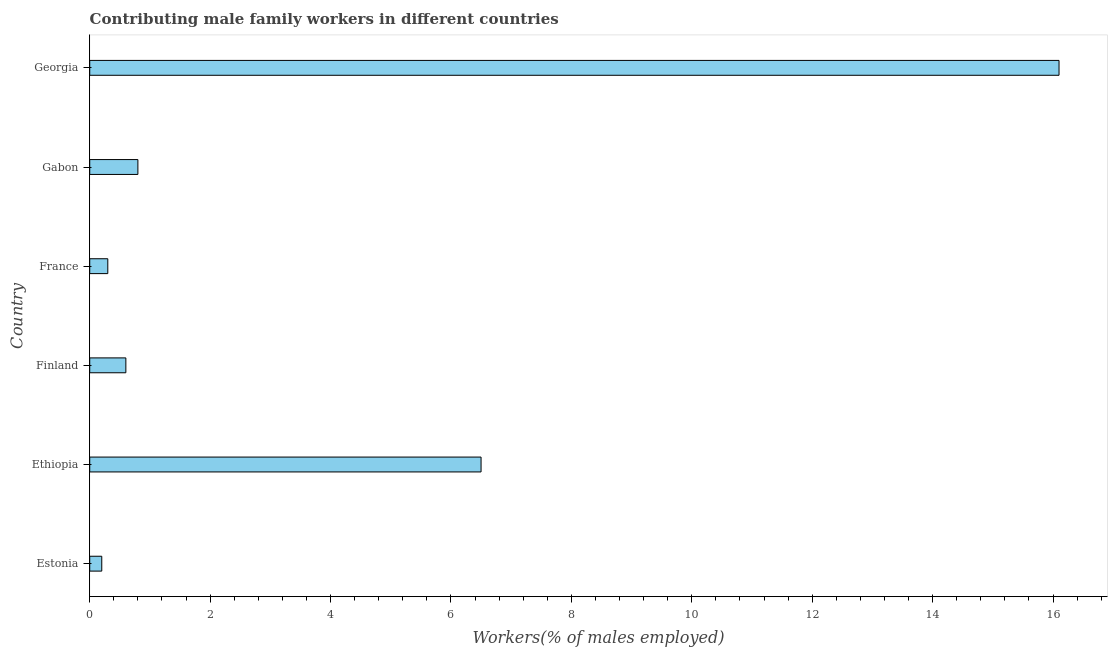What is the title of the graph?
Provide a short and direct response. Contributing male family workers in different countries. What is the label or title of the X-axis?
Provide a short and direct response. Workers(% of males employed). What is the contributing male family workers in Gabon?
Give a very brief answer. 0.8. Across all countries, what is the maximum contributing male family workers?
Provide a succinct answer. 16.1. Across all countries, what is the minimum contributing male family workers?
Your response must be concise. 0.2. In which country was the contributing male family workers maximum?
Offer a terse response. Georgia. In which country was the contributing male family workers minimum?
Your response must be concise. Estonia. What is the sum of the contributing male family workers?
Offer a terse response. 24.5. What is the average contributing male family workers per country?
Offer a terse response. 4.08. What is the median contributing male family workers?
Ensure brevity in your answer.  0.7. What is the ratio of the contributing male family workers in Ethiopia to that in France?
Keep it short and to the point. 21.67. Is the contributing male family workers in Estonia less than that in France?
Offer a terse response. Yes. Is the difference between the contributing male family workers in Estonia and Ethiopia greater than the difference between any two countries?
Keep it short and to the point. No. What is the difference between the highest and the second highest contributing male family workers?
Provide a succinct answer. 9.6. What is the difference between the highest and the lowest contributing male family workers?
Provide a short and direct response. 15.9. In how many countries, is the contributing male family workers greater than the average contributing male family workers taken over all countries?
Give a very brief answer. 2. Are all the bars in the graph horizontal?
Offer a very short reply. Yes. What is the difference between two consecutive major ticks on the X-axis?
Make the answer very short. 2. What is the Workers(% of males employed) of Estonia?
Provide a short and direct response. 0.2. What is the Workers(% of males employed) in Ethiopia?
Keep it short and to the point. 6.5. What is the Workers(% of males employed) in Finland?
Ensure brevity in your answer.  0.6. What is the Workers(% of males employed) in France?
Your response must be concise. 0.3. What is the Workers(% of males employed) of Gabon?
Offer a terse response. 0.8. What is the Workers(% of males employed) of Georgia?
Your answer should be compact. 16.1. What is the difference between the Workers(% of males employed) in Estonia and Ethiopia?
Offer a terse response. -6.3. What is the difference between the Workers(% of males employed) in Estonia and Finland?
Ensure brevity in your answer.  -0.4. What is the difference between the Workers(% of males employed) in Estonia and Georgia?
Keep it short and to the point. -15.9. What is the difference between the Workers(% of males employed) in Ethiopia and Finland?
Ensure brevity in your answer.  5.9. What is the difference between the Workers(% of males employed) in Ethiopia and France?
Ensure brevity in your answer.  6.2. What is the difference between the Workers(% of males employed) in Ethiopia and Gabon?
Your answer should be very brief. 5.7. What is the difference between the Workers(% of males employed) in Ethiopia and Georgia?
Ensure brevity in your answer.  -9.6. What is the difference between the Workers(% of males employed) in Finland and France?
Provide a succinct answer. 0.3. What is the difference between the Workers(% of males employed) in Finland and Georgia?
Keep it short and to the point. -15.5. What is the difference between the Workers(% of males employed) in France and Gabon?
Offer a terse response. -0.5. What is the difference between the Workers(% of males employed) in France and Georgia?
Your answer should be compact. -15.8. What is the difference between the Workers(% of males employed) in Gabon and Georgia?
Your answer should be very brief. -15.3. What is the ratio of the Workers(% of males employed) in Estonia to that in Ethiopia?
Provide a succinct answer. 0.03. What is the ratio of the Workers(% of males employed) in Estonia to that in Finland?
Give a very brief answer. 0.33. What is the ratio of the Workers(% of males employed) in Estonia to that in France?
Keep it short and to the point. 0.67. What is the ratio of the Workers(% of males employed) in Estonia to that in Gabon?
Provide a short and direct response. 0.25. What is the ratio of the Workers(% of males employed) in Estonia to that in Georgia?
Your response must be concise. 0.01. What is the ratio of the Workers(% of males employed) in Ethiopia to that in Finland?
Your response must be concise. 10.83. What is the ratio of the Workers(% of males employed) in Ethiopia to that in France?
Keep it short and to the point. 21.67. What is the ratio of the Workers(% of males employed) in Ethiopia to that in Gabon?
Keep it short and to the point. 8.12. What is the ratio of the Workers(% of males employed) in Ethiopia to that in Georgia?
Offer a very short reply. 0.4. What is the ratio of the Workers(% of males employed) in Finland to that in Gabon?
Provide a short and direct response. 0.75. What is the ratio of the Workers(% of males employed) in Finland to that in Georgia?
Make the answer very short. 0.04. What is the ratio of the Workers(% of males employed) in France to that in Gabon?
Your answer should be very brief. 0.38. What is the ratio of the Workers(% of males employed) in France to that in Georgia?
Ensure brevity in your answer.  0.02. What is the ratio of the Workers(% of males employed) in Gabon to that in Georgia?
Ensure brevity in your answer.  0.05. 